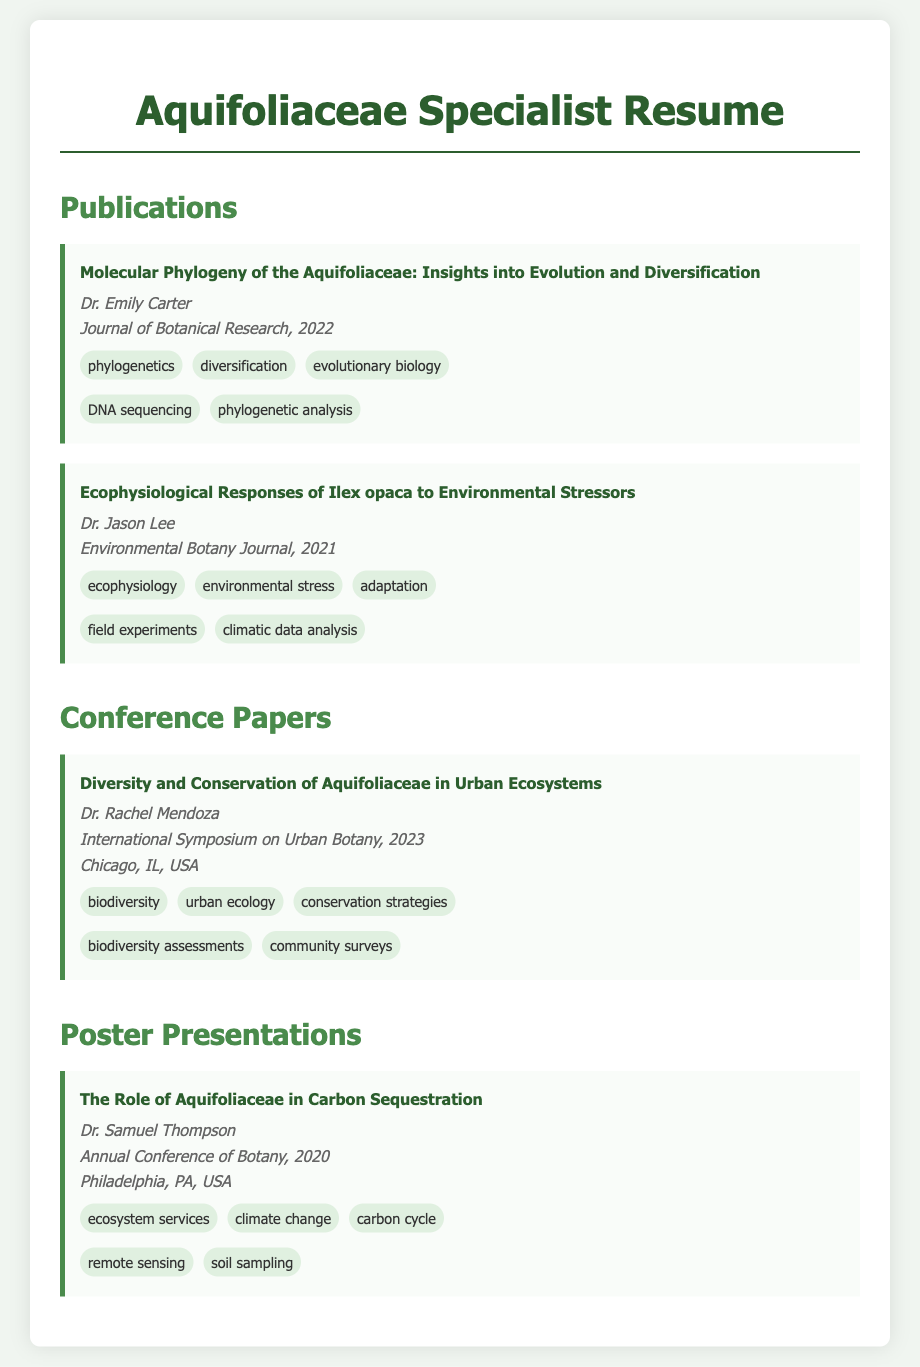what is the title of the publication by Dr. Emily Carter? The title of the publication is the exact phrase presented in the document under Dr. Emily Carter's section.
Answer: Molecular Phylogeny of the Aquifoliaceae: Insights into Evolution and Diversification who authored the conference paper presented at the International Symposium on Urban Botany? The author is listed in the document right under the title of the conference paper.
Answer: Dr. Rachel Mendoza in what year was the poster presentation titled "The Role of Aquifoliaceae in Carbon Sequestration" presented? The year is included in the details of the poster presentation.
Answer: 2020 which methodology was used in the publication focusing on Ilex opaca? This information is found in the methodologies section of that specific publication.
Answer: field experiments what theme relates to the conference paper about urban ecosystems? The themes provided under the conference paper details give this information.
Answer: biodiversity how many themes are mentioned in Dr. Samuel Thompson's poster presentation? The number can be determined by counting the themes listed in his presentation section.
Answer: 3 who published the article in the Journal of Botanical Research? This is answered by identifying the author name associated with the article in the document.
Answer: Dr. Emily Carter what type of document is this compilation categorized under? The specific label of the document that helps to identify its nature is mentioned at the top.
Answer: Resume which location hosted the Annual Conference of Botany in 2020? The location is explicitly mentioned under the details of the poster presentation.
Answer: Philadelphia, PA, USA 